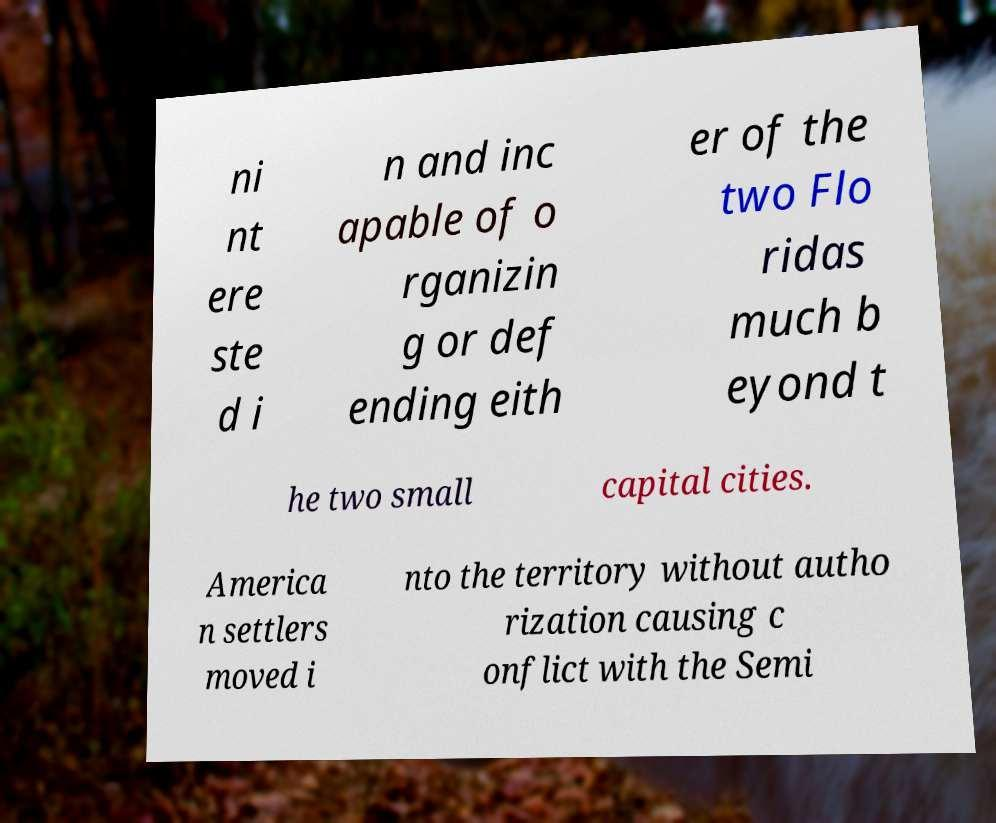Can you accurately transcribe the text from the provided image for me? ni nt ere ste d i n and inc apable of o rganizin g or def ending eith er of the two Flo ridas much b eyond t he two small capital cities. America n settlers moved i nto the territory without autho rization causing c onflict with the Semi 